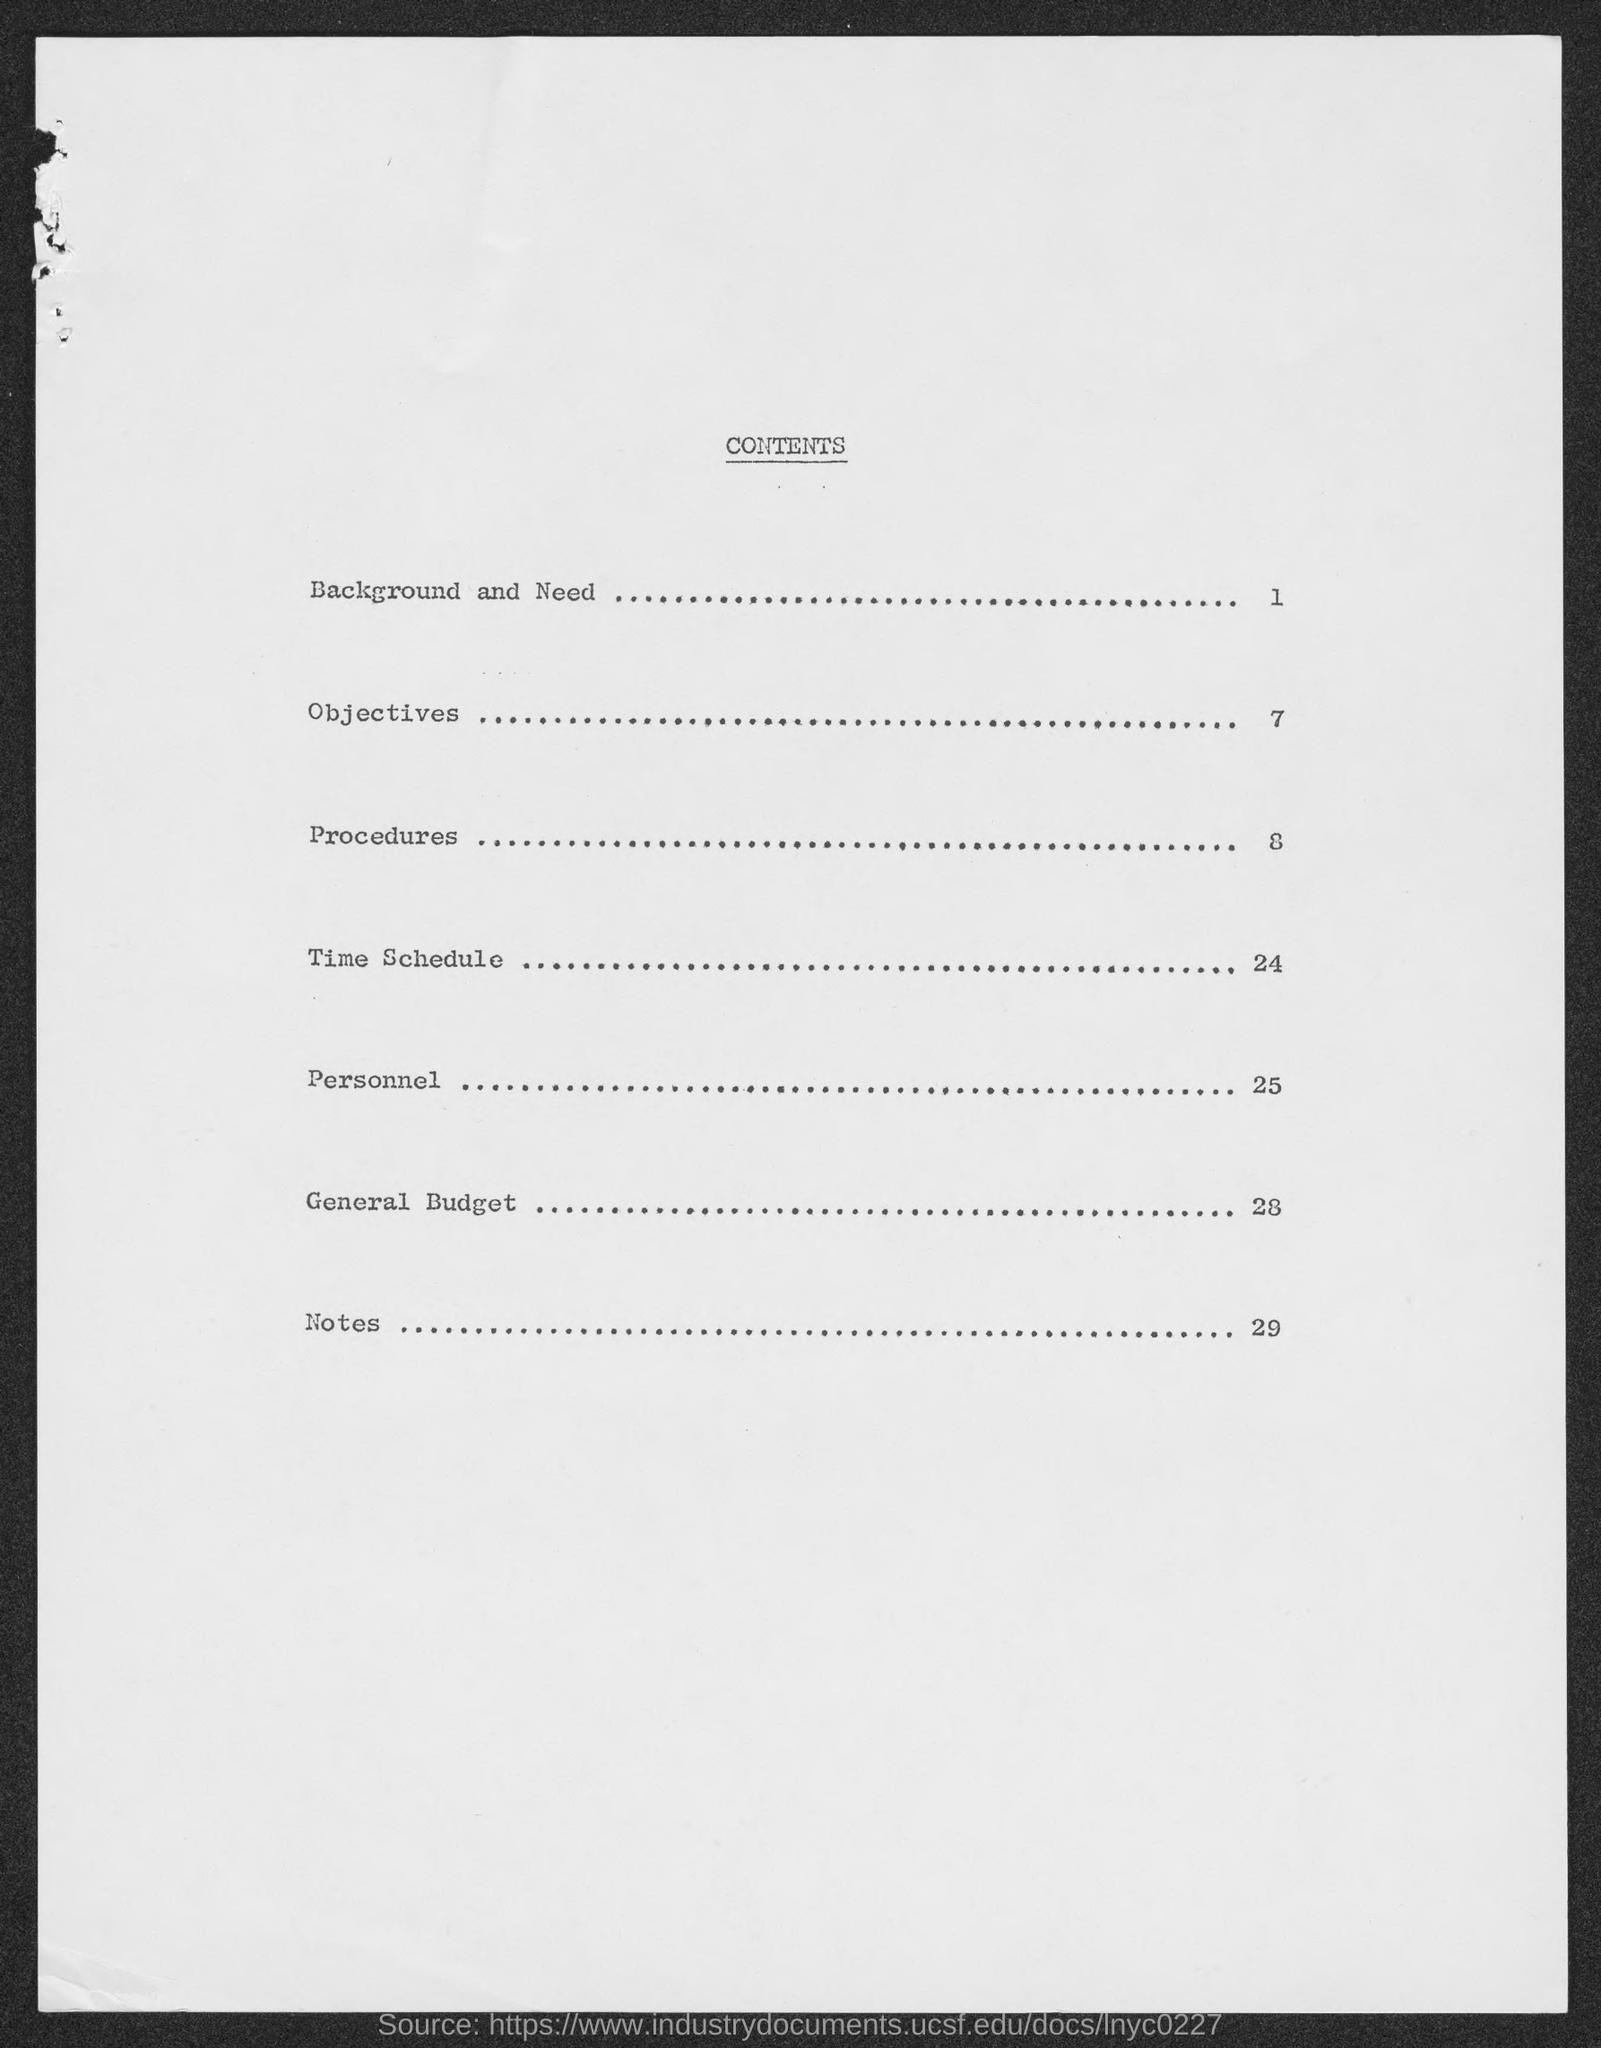In which page number is Background and need?
Provide a succinct answer. 1. What is Subject line of Page 24?
Your answer should be compact. Time Schedule. In which Page General Budget details mentioned here?
Make the answer very short. 28. 